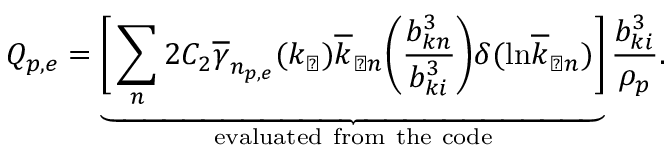<formula> <loc_0><loc_0><loc_500><loc_500>Q _ { p , e } = \underbrace { \left [ \sum _ { n } 2 C _ { 2 } \overline { \gamma } _ { n _ { p , e } } ( k _ { \perp } ) \overline { k } _ { \perp n } \left ( \frac { b _ { k n } ^ { 3 } } { b _ { k i } ^ { 3 } } \right ) \delta ( \ln \overline { k } _ { \perp n } ) \right ] } _ { e v a l u a t e d f r o m t h e c o d e } \frac { b _ { k i } ^ { 3 } } { \rho _ { p } } .</formula> 